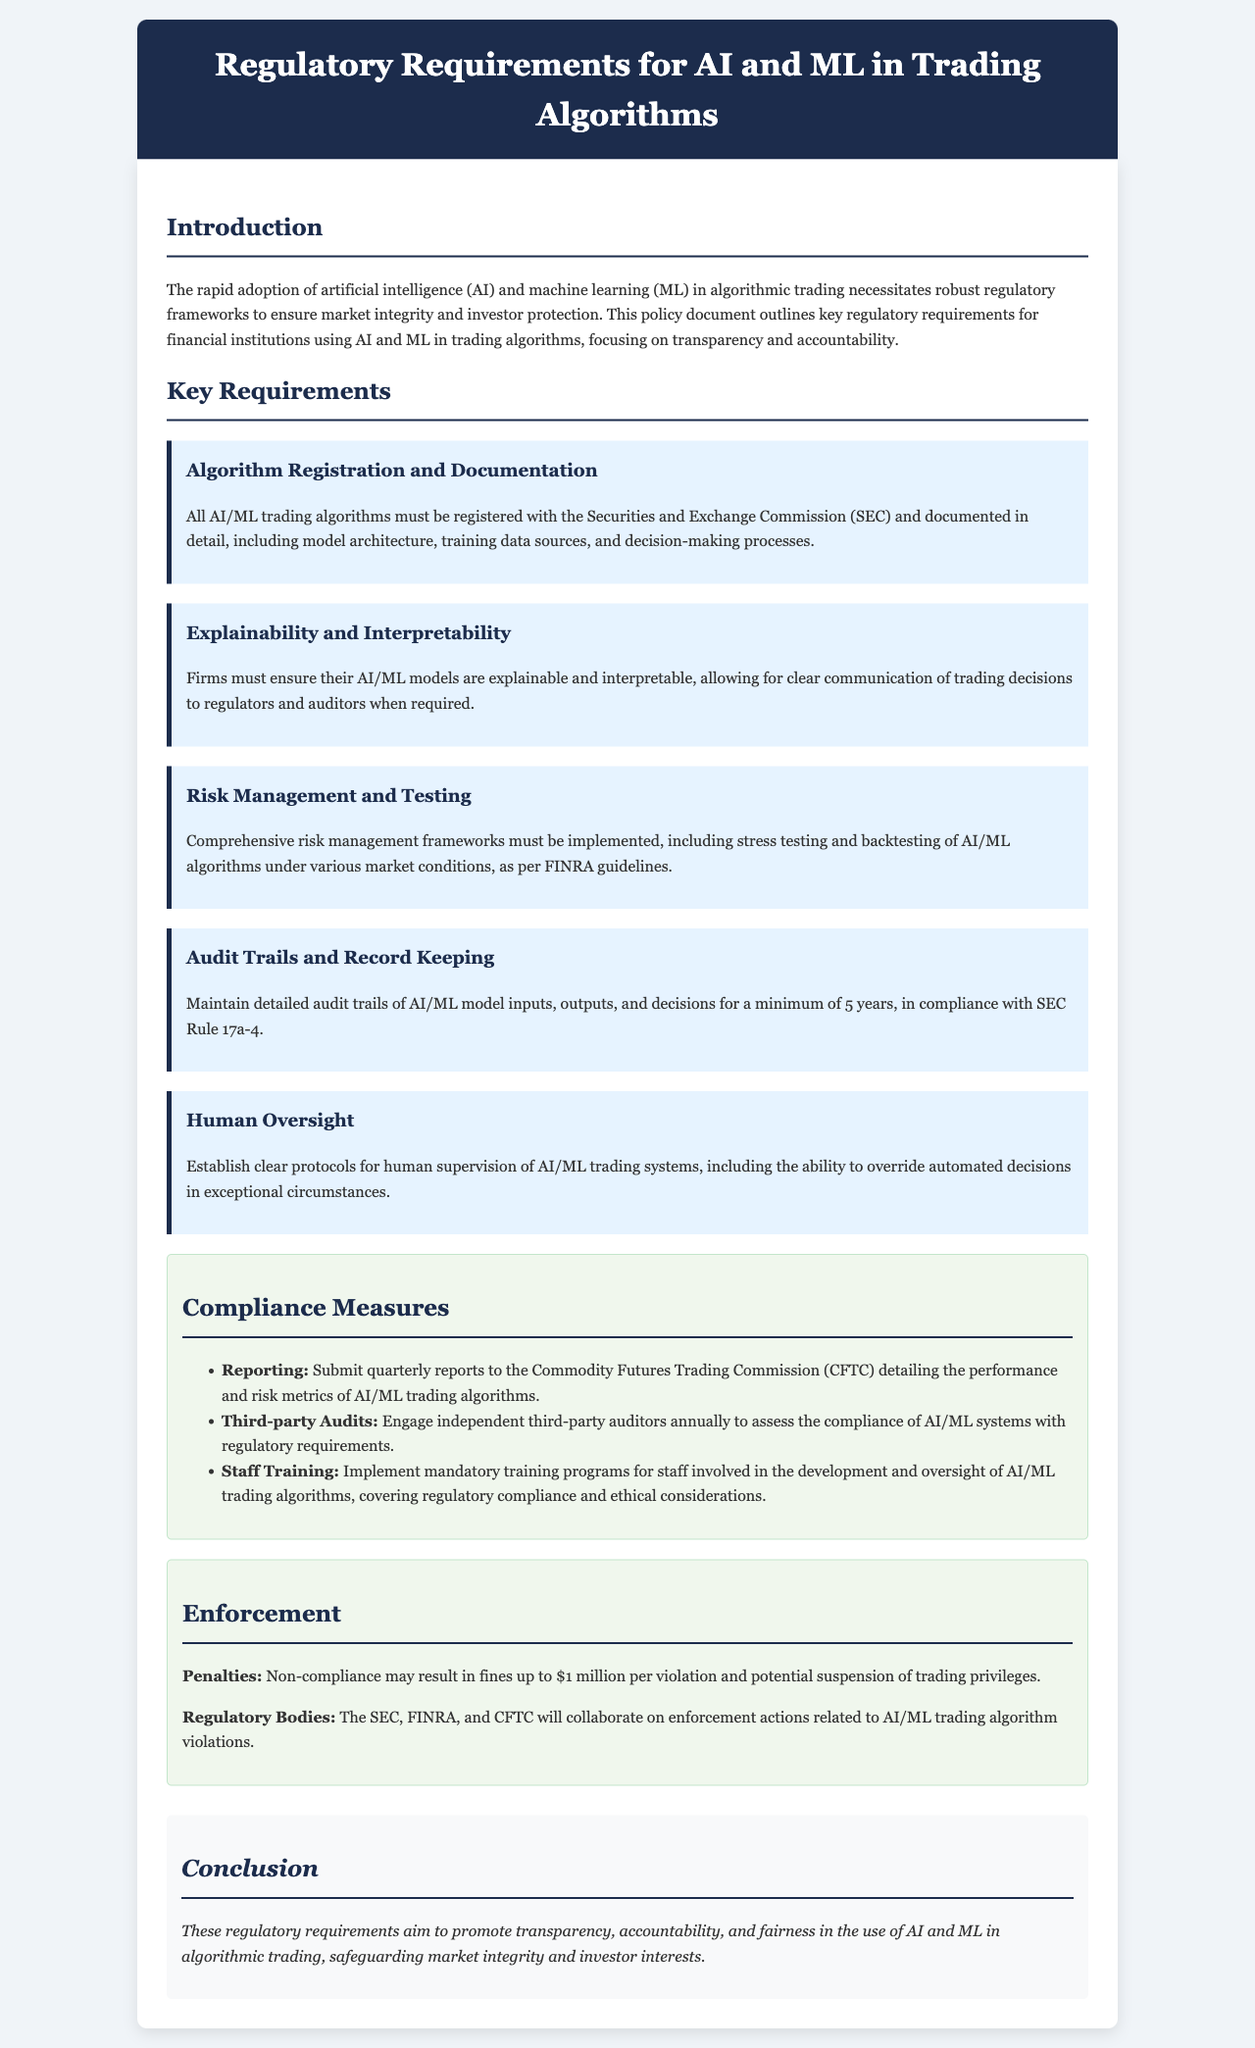What is the minimum duration for maintaining audit trails? The document specifies that firms must maintain detailed audit trails of AI/ML model inputs, outputs, and decisions for a minimum of 5 years.
Answer: 5 years Who must AI/ML trading algorithms be registered with? The algorithms must be registered with the Securities and Exchange Commission.
Answer: Securities and Exchange Commission What is the maximum penalty for non-compliance? The document states that non-compliance may result in fines up to $1 million per violation.
Answer: $1 million What method is required to ensure the explainability of AI/ML models? Firms must ensure their AI/ML models are explainable and interpretable for clear communication of trading decisions.
Answer: Explainable and interpretable Which agency requires quarterly reports on AI/ML trading algorithms? The Commodity Futures Trading Commission requires the submission of quarterly reports.
Answer: Commodity Futures Trading Commission What is a key aspect of the human oversight requirement? Clear protocols for human supervision must be established, including the ability to override automated decisions.
Answer: Ability to override automated decisions What type of training is mandatory for staff involved in AI/ML algorithm development? Staff must undergo mandatory training programs covering regulatory compliance and ethical considerations.
Answer: Mandatory training programs Which regulatory bodies collaborate on enforcement actions? The document lists the SEC, FINRA, and CFTC as collaborating on enforcement actions.
Answer: SEC, FINRA, CFTC 